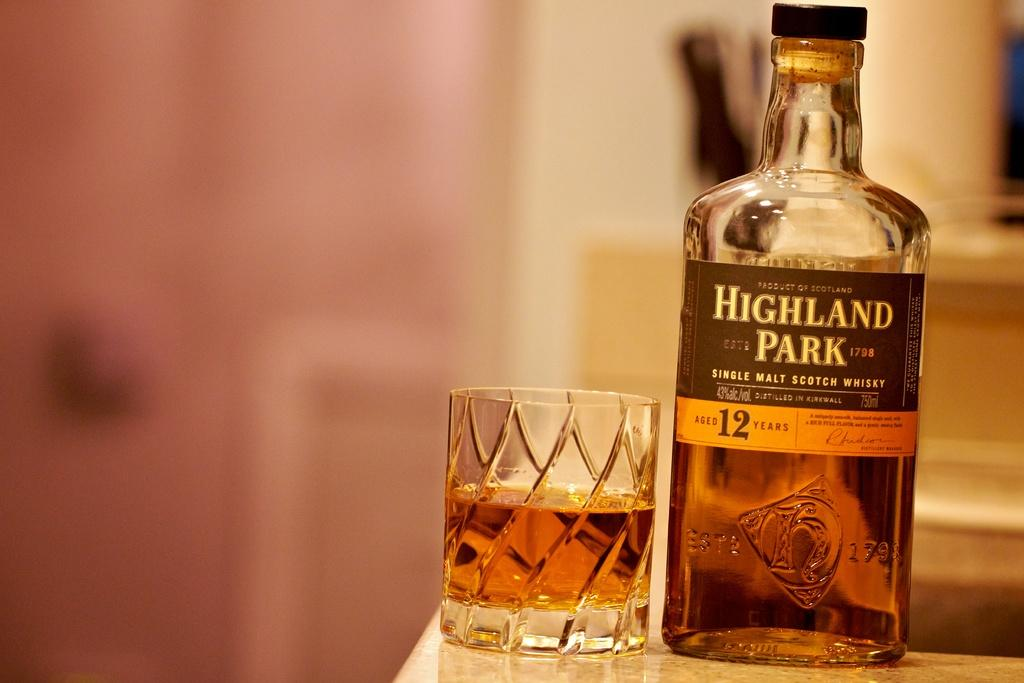<image>
Render a clear and concise summary of the photo. The bottle of Highland Park single malt scotch sits on the counter next to a half full glass. 